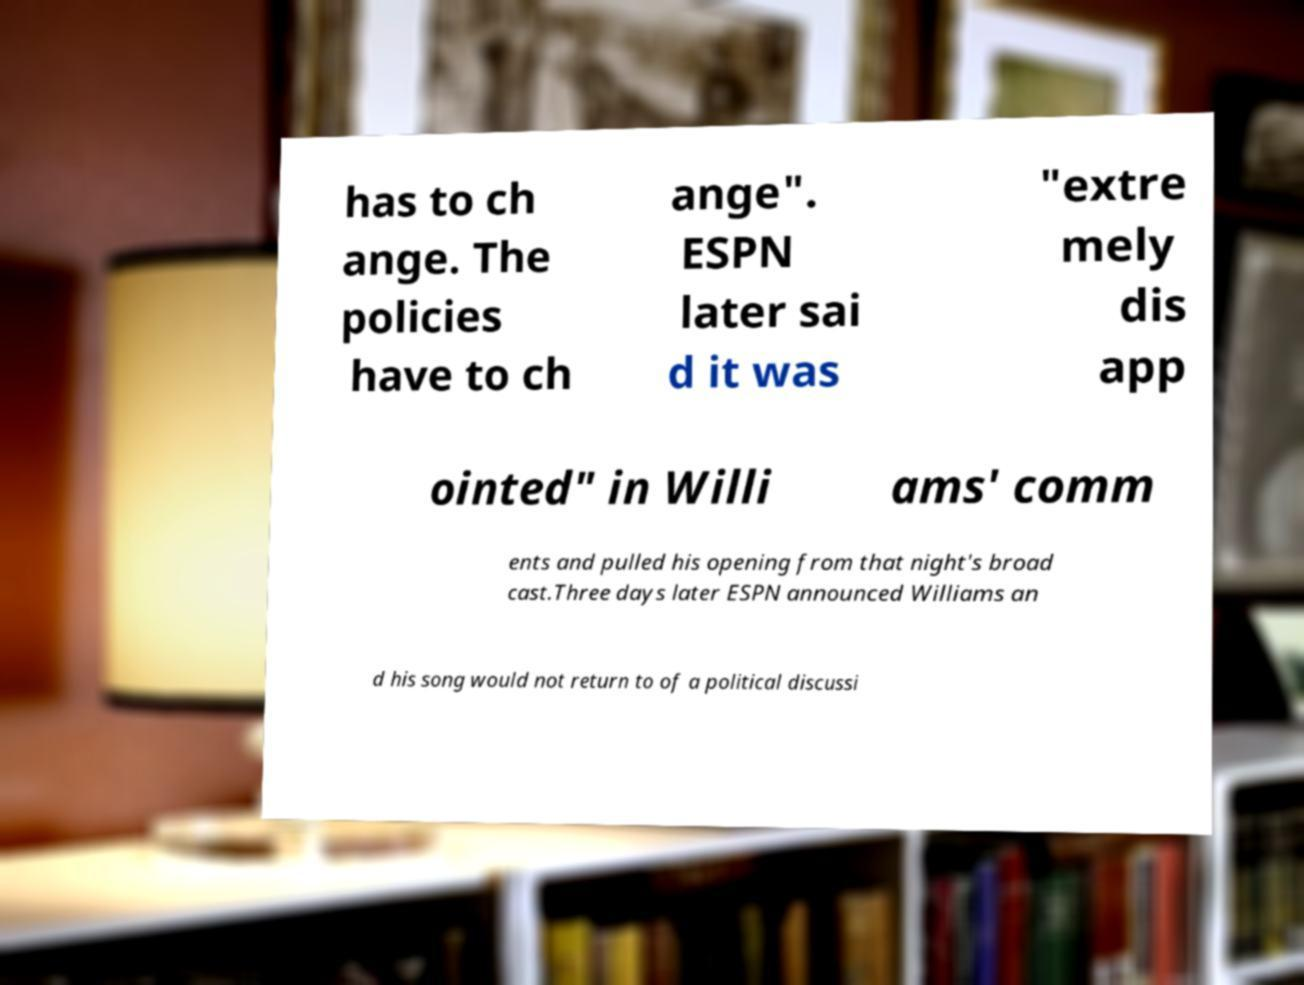What messages or text are displayed in this image? I need them in a readable, typed format. has to ch ange. The policies have to ch ange". ESPN later sai d it was "extre mely dis app ointed" in Willi ams' comm ents and pulled his opening from that night's broad cast.Three days later ESPN announced Williams an d his song would not return to of a political discussi 